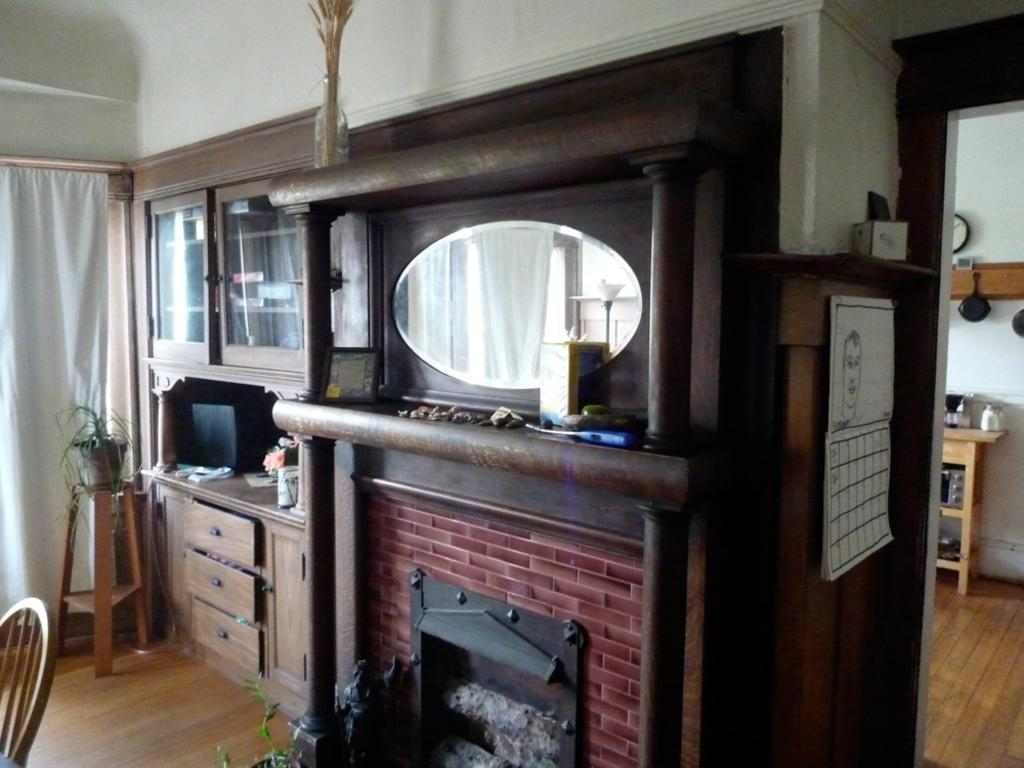What type of structure is present in the image? There is a fireplace in the image. What type of furniture is present in the image? There is a chair in the image. What type of storage unit is present in the image? There is a cupboard in the image. How many lizards can be seen climbing on the cupboard in the image? There are no lizards present in the image. What type of produce is displayed on the fireplace in the image? There is no produce present in the image. 